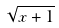Convert formula to latex. <formula><loc_0><loc_0><loc_500><loc_500>\sqrt { x + 1 }</formula> 